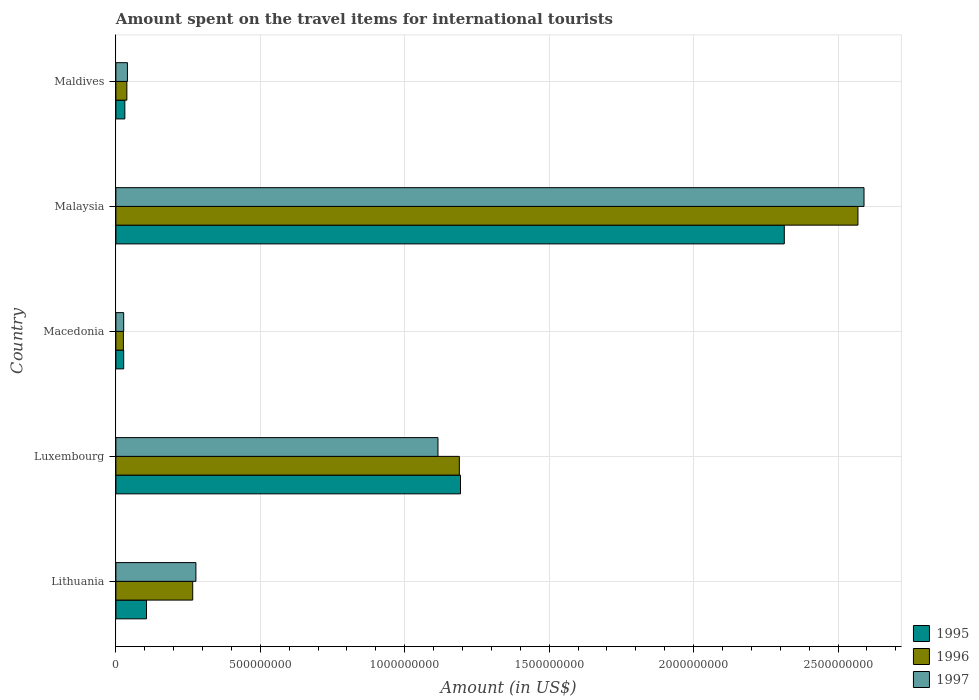Are the number of bars per tick equal to the number of legend labels?
Keep it short and to the point. Yes. How many bars are there on the 2nd tick from the top?
Give a very brief answer. 3. What is the label of the 2nd group of bars from the top?
Keep it short and to the point. Malaysia. In how many cases, is the number of bars for a given country not equal to the number of legend labels?
Your answer should be compact. 0. What is the amount spent on the travel items for international tourists in 1995 in Luxembourg?
Make the answer very short. 1.19e+09. Across all countries, what is the maximum amount spent on the travel items for international tourists in 1996?
Ensure brevity in your answer.  2.57e+09. Across all countries, what is the minimum amount spent on the travel items for international tourists in 1995?
Offer a terse response. 2.70e+07. In which country was the amount spent on the travel items for international tourists in 1996 maximum?
Your response must be concise. Malaysia. In which country was the amount spent on the travel items for international tourists in 1995 minimum?
Keep it short and to the point. Macedonia. What is the total amount spent on the travel items for international tourists in 1997 in the graph?
Provide a succinct answer. 4.05e+09. What is the difference between the amount spent on the travel items for international tourists in 1997 in Malaysia and that in Maldives?
Your answer should be compact. 2.55e+09. What is the difference between the amount spent on the travel items for international tourists in 1995 in Malaysia and the amount spent on the travel items for international tourists in 1997 in Lithuania?
Keep it short and to the point. 2.04e+09. What is the average amount spent on the travel items for international tourists in 1995 per country?
Make the answer very short. 7.34e+08. What is the difference between the amount spent on the travel items for international tourists in 1997 and amount spent on the travel items for international tourists in 1996 in Malaysia?
Provide a succinct answer. 2.10e+07. In how many countries, is the amount spent on the travel items for international tourists in 1996 greater than 1400000000 US$?
Ensure brevity in your answer.  1. What is the ratio of the amount spent on the travel items for international tourists in 1997 in Macedonia to that in Malaysia?
Your response must be concise. 0.01. What is the difference between the highest and the second highest amount spent on the travel items for international tourists in 1996?
Offer a terse response. 1.38e+09. What is the difference between the highest and the lowest amount spent on the travel items for international tourists in 1997?
Make the answer very short. 2.56e+09. In how many countries, is the amount spent on the travel items for international tourists in 1995 greater than the average amount spent on the travel items for international tourists in 1995 taken over all countries?
Provide a short and direct response. 2. Is the sum of the amount spent on the travel items for international tourists in 1997 in Lithuania and Malaysia greater than the maximum amount spent on the travel items for international tourists in 1995 across all countries?
Ensure brevity in your answer.  Yes. What does the 1st bar from the bottom in Macedonia represents?
Your answer should be very brief. 1995. Is it the case that in every country, the sum of the amount spent on the travel items for international tourists in 1996 and amount spent on the travel items for international tourists in 1997 is greater than the amount spent on the travel items for international tourists in 1995?
Your answer should be compact. Yes. How many bars are there?
Keep it short and to the point. 15. Are all the bars in the graph horizontal?
Your response must be concise. Yes. How many countries are there in the graph?
Make the answer very short. 5. Does the graph contain any zero values?
Offer a terse response. No. Does the graph contain grids?
Provide a short and direct response. Yes. How many legend labels are there?
Give a very brief answer. 3. How are the legend labels stacked?
Your answer should be very brief. Vertical. What is the title of the graph?
Provide a short and direct response. Amount spent on the travel items for international tourists. What is the label or title of the X-axis?
Your answer should be compact. Amount (in US$). What is the label or title of the Y-axis?
Your answer should be very brief. Country. What is the Amount (in US$) of 1995 in Lithuania?
Your response must be concise. 1.06e+08. What is the Amount (in US$) of 1996 in Lithuania?
Keep it short and to the point. 2.66e+08. What is the Amount (in US$) of 1997 in Lithuania?
Your response must be concise. 2.77e+08. What is the Amount (in US$) of 1995 in Luxembourg?
Your answer should be very brief. 1.19e+09. What is the Amount (in US$) of 1996 in Luxembourg?
Your response must be concise. 1.19e+09. What is the Amount (in US$) of 1997 in Luxembourg?
Provide a short and direct response. 1.12e+09. What is the Amount (in US$) of 1995 in Macedonia?
Your answer should be compact. 2.70e+07. What is the Amount (in US$) in 1996 in Macedonia?
Ensure brevity in your answer.  2.60e+07. What is the Amount (in US$) in 1997 in Macedonia?
Your answer should be very brief. 2.70e+07. What is the Amount (in US$) of 1995 in Malaysia?
Your response must be concise. 2.31e+09. What is the Amount (in US$) of 1996 in Malaysia?
Provide a short and direct response. 2.57e+09. What is the Amount (in US$) in 1997 in Malaysia?
Keep it short and to the point. 2.59e+09. What is the Amount (in US$) in 1995 in Maldives?
Give a very brief answer. 3.10e+07. What is the Amount (in US$) in 1996 in Maldives?
Give a very brief answer. 3.80e+07. What is the Amount (in US$) in 1997 in Maldives?
Your answer should be very brief. 4.00e+07. Across all countries, what is the maximum Amount (in US$) in 1995?
Offer a terse response. 2.31e+09. Across all countries, what is the maximum Amount (in US$) in 1996?
Provide a succinct answer. 2.57e+09. Across all countries, what is the maximum Amount (in US$) of 1997?
Offer a very short reply. 2.59e+09. Across all countries, what is the minimum Amount (in US$) in 1995?
Your answer should be compact. 2.70e+07. Across all countries, what is the minimum Amount (in US$) in 1996?
Your answer should be very brief. 2.60e+07. Across all countries, what is the minimum Amount (in US$) of 1997?
Your response must be concise. 2.70e+07. What is the total Amount (in US$) of 1995 in the graph?
Your response must be concise. 3.67e+09. What is the total Amount (in US$) in 1996 in the graph?
Your response must be concise. 4.09e+09. What is the total Amount (in US$) in 1997 in the graph?
Your answer should be compact. 4.05e+09. What is the difference between the Amount (in US$) of 1995 in Lithuania and that in Luxembourg?
Provide a short and direct response. -1.09e+09. What is the difference between the Amount (in US$) of 1996 in Lithuania and that in Luxembourg?
Make the answer very short. -9.23e+08. What is the difference between the Amount (in US$) in 1997 in Lithuania and that in Luxembourg?
Provide a succinct answer. -8.38e+08. What is the difference between the Amount (in US$) of 1995 in Lithuania and that in Macedonia?
Offer a very short reply. 7.90e+07. What is the difference between the Amount (in US$) in 1996 in Lithuania and that in Macedonia?
Ensure brevity in your answer.  2.40e+08. What is the difference between the Amount (in US$) in 1997 in Lithuania and that in Macedonia?
Your answer should be very brief. 2.50e+08. What is the difference between the Amount (in US$) of 1995 in Lithuania and that in Malaysia?
Your response must be concise. -2.21e+09. What is the difference between the Amount (in US$) of 1996 in Lithuania and that in Malaysia?
Make the answer very short. -2.30e+09. What is the difference between the Amount (in US$) of 1997 in Lithuania and that in Malaysia?
Keep it short and to the point. -2.31e+09. What is the difference between the Amount (in US$) in 1995 in Lithuania and that in Maldives?
Make the answer very short. 7.50e+07. What is the difference between the Amount (in US$) in 1996 in Lithuania and that in Maldives?
Give a very brief answer. 2.28e+08. What is the difference between the Amount (in US$) in 1997 in Lithuania and that in Maldives?
Your response must be concise. 2.37e+08. What is the difference between the Amount (in US$) of 1995 in Luxembourg and that in Macedonia?
Offer a terse response. 1.17e+09. What is the difference between the Amount (in US$) in 1996 in Luxembourg and that in Macedonia?
Provide a short and direct response. 1.16e+09. What is the difference between the Amount (in US$) in 1997 in Luxembourg and that in Macedonia?
Your answer should be compact. 1.09e+09. What is the difference between the Amount (in US$) of 1995 in Luxembourg and that in Malaysia?
Keep it short and to the point. -1.12e+09. What is the difference between the Amount (in US$) in 1996 in Luxembourg and that in Malaysia?
Your answer should be very brief. -1.38e+09. What is the difference between the Amount (in US$) of 1997 in Luxembourg and that in Malaysia?
Provide a short and direct response. -1.48e+09. What is the difference between the Amount (in US$) of 1995 in Luxembourg and that in Maldives?
Your answer should be compact. 1.16e+09. What is the difference between the Amount (in US$) of 1996 in Luxembourg and that in Maldives?
Offer a terse response. 1.15e+09. What is the difference between the Amount (in US$) in 1997 in Luxembourg and that in Maldives?
Provide a succinct answer. 1.08e+09. What is the difference between the Amount (in US$) in 1995 in Macedonia and that in Malaysia?
Provide a short and direct response. -2.29e+09. What is the difference between the Amount (in US$) in 1996 in Macedonia and that in Malaysia?
Give a very brief answer. -2.54e+09. What is the difference between the Amount (in US$) of 1997 in Macedonia and that in Malaysia?
Keep it short and to the point. -2.56e+09. What is the difference between the Amount (in US$) of 1996 in Macedonia and that in Maldives?
Keep it short and to the point. -1.20e+07. What is the difference between the Amount (in US$) of 1997 in Macedonia and that in Maldives?
Provide a short and direct response. -1.30e+07. What is the difference between the Amount (in US$) in 1995 in Malaysia and that in Maldives?
Your answer should be compact. 2.28e+09. What is the difference between the Amount (in US$) of 1996 in Malaysia and that in Maldives?
Your response must be concise. 2.53e+09. What is the difference between the Amount (in US$) of 1997 in Malaysia and that in Maldives?
Your answer should be compact. 2.55e+09. What is the difference between the Amount (in US$) in 1995 in Lithuania and the Amount (in US$) in 1996 in Luxembourg?
Give a very brief answer. -1.08e+09. What is the difference between the Amount (in US$) of 1995 in Lithuania and the Amount (in US$) of 1997 in Luxembourg?
Make the answer very short. -1.01e+09. What is the difference between the Amount (in US$) in 1996 in Lithuania and the Amount (in US$) in 1997 in Luxembourg?
Your response must be concise. -8.49e+08. What is the difference between the Amount (in US$) of 1995 in Lithuania and the Amount (in US$) of 1996 in Macedonia?
Provide a succinct answer. 8.00e+07. What is the difference between the Amount (in US$) of 1995 in Lithuania and the Amount (in US$) of 1997 in Macedonia?
Your response must be concise. 7.90e+07. What is the difference between the Amount (in US$) in 1996 in Lithuania and the Amount (in US$) in 1997 in Macedonia?
Provide a succinct answer. 2.39e+08. What is the difference between the Amount (in US$) of 1995 in Lithuania and the Amount (in US$) of 1996 in Malaysia?
Provide a short and direct response. -2.46e+09. What is the difference between the Amount (in US$) in 1995 in Lithuania and the Amount (in US$) in 1997 in Malaysia?
Offer a terse response. -2.48e+09. What is the difference between the Amount (in US$) of 1996 in Lithuania and the Amount (in US$) of 1997 in Malaysia?
Provide a short and direct response. -2.32e+09. What is the difference between the Amount (in US$) of 1995 in Lithuania and the Amount (in US$) of 1996 in Maldives?
Give a very brief answer. 6.80e+07. What is the difference between the Amount (in US$) in 1995 in Lithuania and the Amount (in US$) in 1997 in Maldives?
Provide a succinct answer. 6.60e+07. What is the difference between the Amount (in US$) of 1996 in Lithuania and the Amount (in US$) of 1997 in Maldives?
Your answer should be compact. 2.26e+08. What is the difference between the Amount (in US$) in 1995 in Luxembourg and the Amount (in US$) in 1996 in Macedonia?
Make the answer very short. 1.17e+09. What is the difference between the Amount (in US$) in 1995 in Luxembourg and the Amount (in US$) in 1997 in Macedonia?
Your answer should be very brief. 1.17e+09. What is the difference between the Amount (in US$) in 1996 in Luxembourg and the Amount (in US$) in 1997 in Macedonia?
Your answer should be very brief. 1.16e+09. What is the difference between the Amount (in US$) in 1995 in Luxembourg and the Amount (in US$) in 1996 in Malaysia?
Provide a short and direct response. -1.38e+09. What is the difference between the Amount (in US$) of 1995 in Luxembourg and the Amount (in US$) of 1997 in Malaysia?
Your response must be concise. -1.40e+09. What is the difference between the Amount (in US$) in 1996 in Luxembourg and the Amount (in US$) in 1997 in Malaysia?
Provide a succinct answer. -1.40e+09. What is the difference between the Amount (in US$) of 1995 in Luxembourg and the Amount (in US$) of 1996 in Maldives?
Make the answer very short. 1.16e+09. What is the difference between the Amount (in US$) in 1995 in Luxembourg and the Amount (in US$) in 1997 in Maldives?
Make the answer very short. 1.15e+09. What is the difference between the Amount (in US$) in 1996 in Luxembourg and the Amount (in US$) in 1997 in Maldives?
Offer a very short reply. 1.15e+09. What is the difference between the Amount (in US$) of 1995 in Macedonia and the Amount (in US$) of 1996 in Malaysia?
Provide a succinct answer. -2.54e+09. What is the difference between the Amount (in US$) in 1995 in Macedonia and the Amount (in US$) in 1997 in Malaysia?
Offer a very short reply. -2.56e+09. What is the difference between the Amount (in US$) in 1996 in Macedonia and the Amount (in US$) in 1997 in Malaysia?
Offer a terse response. -2.56e+09. What is the difference between the Amount (in US$) in 1995 in Macedonia and the Amount (in US$) in 1996 in Maldives?
Provide a short and direct response. -1.10e+07. What is the difference between the Amount (in US$) in 1995 in Macedonia and the Amount (in US$) in 1997 in Maldives?
Your answer should be compact. -1.30e+07. What is the difference between the Amount (in US$) of 1996 in Macedonia and the Amount (in US$) of 1997 in Maldives?
Ensure brevity in your answer.  -1.40e+07. What is the difference between the Amount (in US$) in 1995 in Malaysia and the Amount (in US$) in 1996 in Maldives?
Offer a very short reply. 2.28e+09. What is the difference between the Amount (in US$) of 1995 in Malaysia and the Amount (in US$) of 1997 in Maldives?
Your response must be concise. 2.27e+09. What is the difference between the Amount (in US$) in 1996 in Malaysia and the Amount (in US$) in 1997 in Maldives?
Your response must be concise. 2.53e+09. What is the average Amount (in US$) of 1995 per country?
Give a very brief answer. 7.34e+08. What is the average Amount (in US$) in 1996 per country?
Provide a succinct answer. 8.18e+08. What is the average Amount (in US$) in 1997 per country?
Offer a terse response. 8.10e+08. What is the difference between the Amount (in US$) in 1995 and Amount (in US$) in 1996 in Lithuania?
Your answer should be compact. -1.60e+08. What is the difference between the Amount (in US$) in 1995 and Amount (in US$) in 1997 in Lithuania?
Offer a very short reply. -1.71e+08. What is the difference between the Amount (in US$) of 1996 and Amount (in US$) of 1997 in Lithuania?
Give a very brief answer. -1.10e+07. What is the difference between the Amount (in US$) of 1995 and Amount (in US$) of 1997 in Luxembourg?
Offer a very short reply. 7.80e+07. What is the difference between the Amount (in US$) in 1996 and Amount (in US$) in 1997 in Luxembourg?
Your response must be concise. 7.40e+07. What is the difference between the Amount (in US$) of 1995 and Amount (in US$) of 1996 in Macedonia?
Your answer should be very brief. 1.00e+06. What is the difference between the Amount (in US$) in 1995 and Amount (in US$) in 1997 in Macedonia?
Ensure brevity in your answer.  0. What is the difference between the Amount (in US$) of 1995 and Amount (in US$) of 1996 in Malaysia?
Give a very brief answer. -2.55e+08. What is the difference between the Amount (in US$) of 1995 and Amount (in US$) of 1997 in Malaysia?
Make the answer very short. -2.76e+08. What is the difference between the Amount (in US$) of 1996 and Amount (in US$) of 1997 in Malaysia?
Keep it short and to the point. -2.10e+07. What is the difference between the Amount (in US$) of 1995 and Amount (in US$) of 1996 in Maldives?
Ensure brevity in your answer.  -7.00e+06. What is the difference between the Amount (in US$) in 1995 and Amount (in US$) in 1997 in Maldives?
Your response must be concise. -9.00e+06. What is the ratio of the Amount (in US$) in 1995 in Lithuania to that in Luxembourg?
Make the answer very short. 0.09. What is the ratio of the Amount (in US$) of 1996 in Lithuania to that in Luxembourg?
Ensure brevity in your answer.  0.22. What is the ratio of the Amount (in US$) of 1997 in Lithuania to that in Luxembourg?
Keep it short and to the point. 0.25. What is the ratio of the Amount (in US$) of 1995 in Lithuania to that in Macedonia?
Make the answer very short. 3.93. What is the ratio of the Amount (in US$) in 1996 in Lithuania to that in Macedonia?
Your response must be concise. 10.23. What is the ratio of the Amount (in US$) of 1997 in Lithuania to that in Macedonia?
Keep it short and to the point. 10.26. What is the ratio of the Amount (in US$) of 1995 in Lithuania to that in Malaysia?
Give a very brief answer. 0.05. What is the ratio of the Amount (in US$) of 1996 in Lithuania to that in Malaysia?
Ensure brevity in your answer.  0.1. What is the ratio of the Amount (in US$) in 1997 in Lithuania to that in Malaysia?
Your answer should be compact. 0.11. What is the ratio of the Amount (in US$) of 1995 in Lithuania to that in Maldives?
Offer a very short reply. 3.42. What is the ratio of the Amount (in US$) in 1997 in Lithuania to that in Maldives?
Your answer should be very brief. 6.92. What is the ratio of the Amount (in US$) in 1995 in Luxembourg to that in Macedonia?
Ensure brevity in your answer.  44.19. What is the ratio of the Amount (in US$) in 1996 in Luxembourg to that in Macedonia?
Provide a succinct answer. 45.73. What is the ratio of the Amount (in US$) of 1997 in Luxembourg to that in Macedonia?
Provide a short and direct response. 41.3. What is the ratio of the Amount (in US$) in 1995 in Luxembourg to that in Malaysia?
Offer a very short reply. 0.52. What is the ratio of the Amount (in US$) in 1996 in Luxembourg to that in Malaysia?
Offer a terse response. 0.46. What is the ratio of the Amount (in US$) in 1997 in Luxembourg to that in Malaysia?
Provide a short and direct response. 0.43. What is the ratio of the Amount (in US$) in 1995 in Luxembourg to that in Maldives?
Your answer should be compact. 38.48. What is the ratio of the Amount (in US$) in 1996 in Luxembourg to that in Maldives?
Your answer should be very brief. 31.29. What is the ratio of the Amount (in US$) of 1997 in Luxembourg to that in Maldives?
Provide a short and direct response. 27.88. What is the ratio of the Amount (in US$) in 1995 in Macedonia to that in Malaysia?
Make the answer very short. 0.01. What is the ratio of the Amount (in US$) in 1996 in Macedonia to that in Malaysia?
Provide a succinct answer. 0.01. What is the ratio of the Amount (in US$) of 1997 in Macedonia to that in Malaysia?
Give a very brief answer. 0.01. What is the ratio of the Amount (in US$) in 1995 in Macedonia to that in Maldives?
Ensure brevity in your answer.  0.87. What is the ratio of the Amount (in US$) of 1996 in Macedonia to that in Maldives?
Offer a terse response. 0.68. What is the ratio of the Amount (in US$) of 1997 in Macedonia to that in Maldives?
Give a very brief answer. 0.68. What is the ratio of the Amount (in US$) in 1995 in Malaysia to that in Maldives?
Keep it short and to the point. 74.65. What is the ratio of the Amount (in US$) in 1996 in Malaysia to that in Maldives?
Give a very brief answer. 67.61. What is the ratio of the Amount (in US$) of 1997 in Malaysia to that in Maldives?
Give a very brief answer. 64.75. What is the difference between the highest and the second highest Amount (in US$) in 1995?
Keep it short and to the point. 1.12e+09. What is the difference between the highest and the second highest Amount (in US$) in 1996?
Ensure brevity in your answer.  1.38e+09. What is the difference between the highest and the second highest Amount (in US$) of 1997?
Ensure brevity in your answer.  1.48e+09. What is the difference between the highest and the lowest Amount (in US$) of 1995?
Give a very brief answer. 2.29e+09. What is the difference between the highest and the lowest Amount (in US$) in 1996?
Provide a short and direct response. 2.54e+09. What is the difference between the highest and the lowest Amount (in US$) of 1997?
Ensure brevity in your answer.  2.56e+09. 